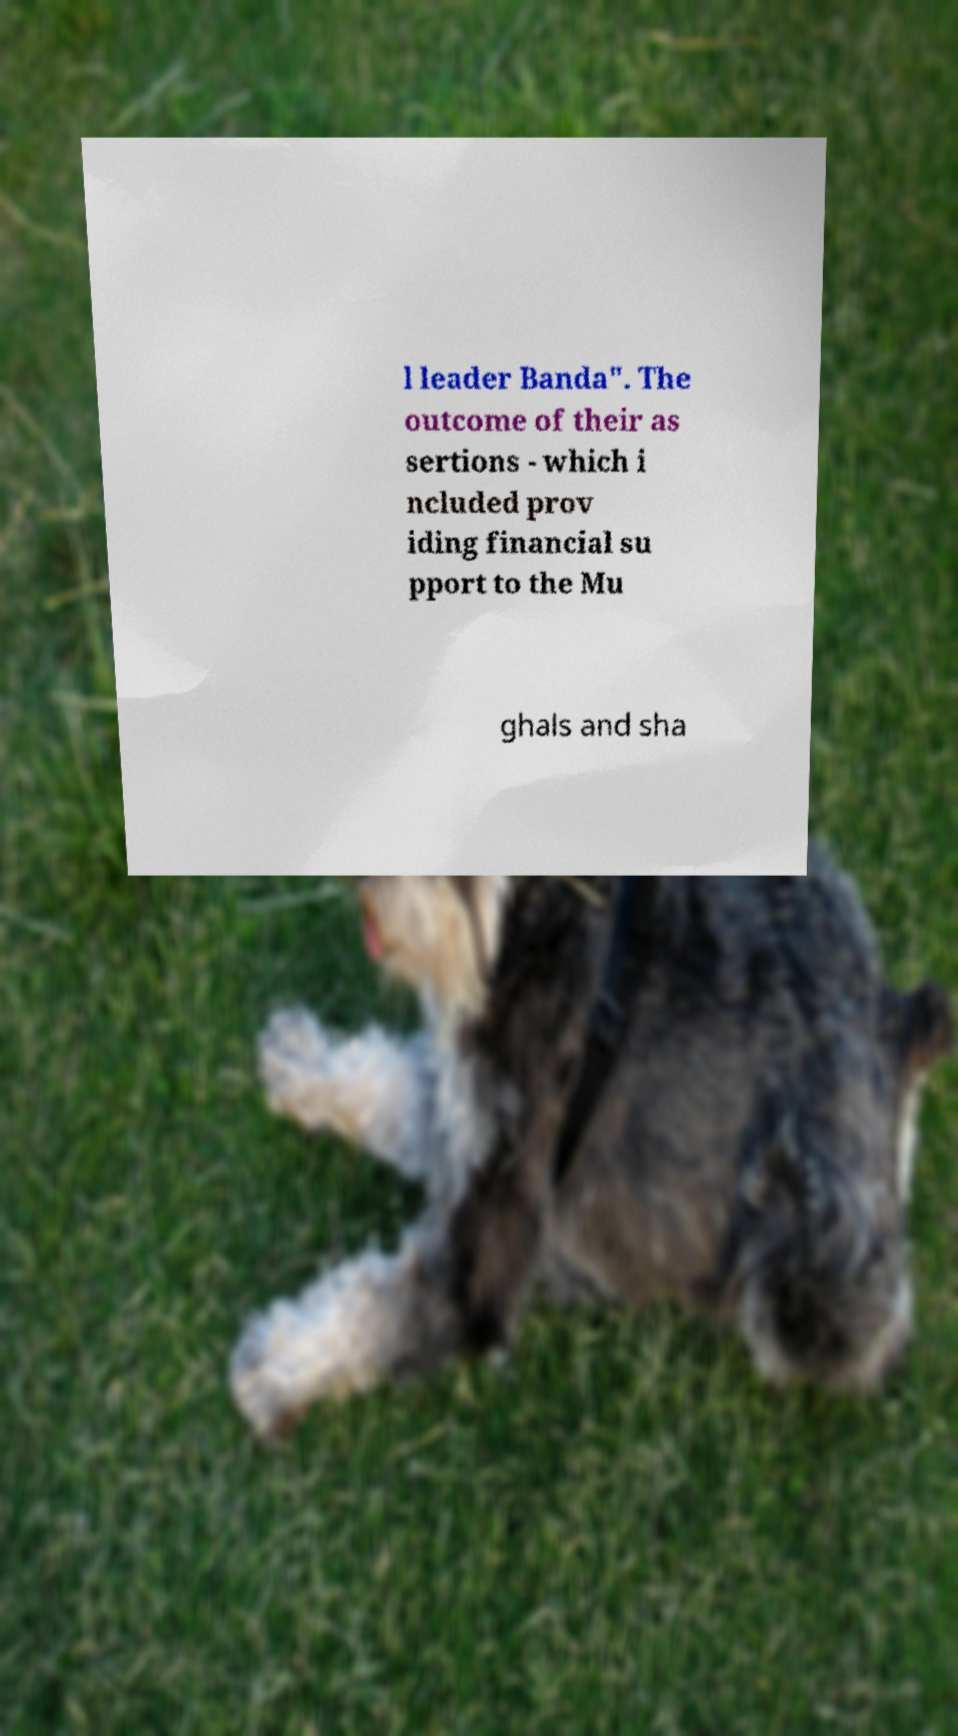Can you read and provide the text displayed in the image?This photo seems to have some interesting text. Can you extract and type it out for me? l leader Banda". The outcome of their as sertions - which i ncluded prov iding financial su pport to the Mu ghals and sha 